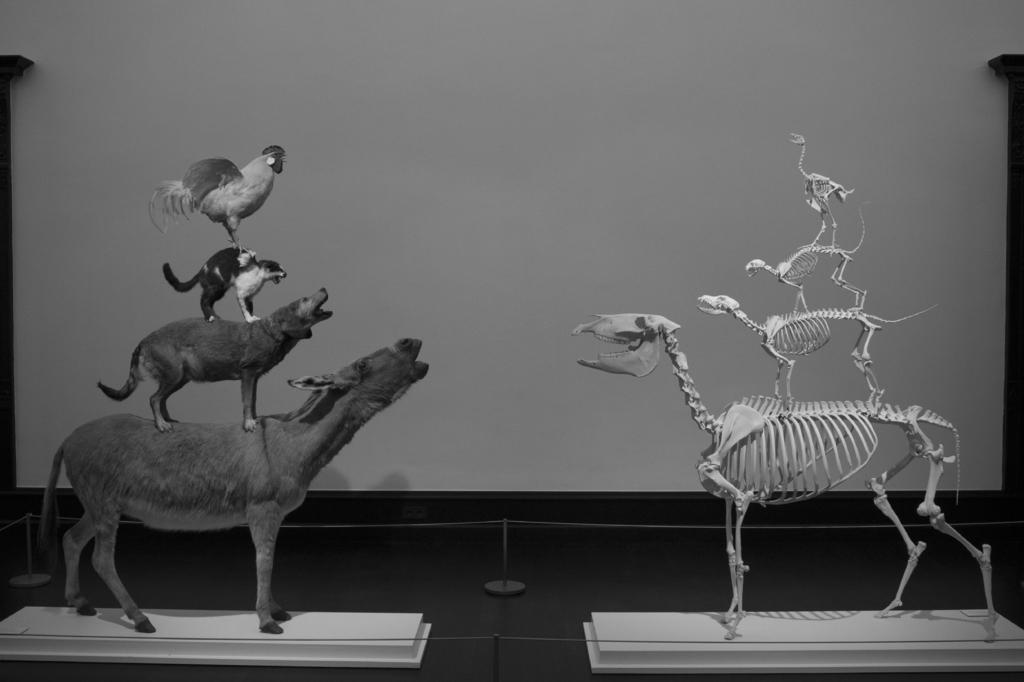What is the color scheme of the image? The image is black and white. What type of living creatures are present in the image? There are animals in the image, including a hen. What can be seen on the pedestals in the image? There are skeletons on pedestals in the image. What is visible in the background of the image? There is a wall in the background of the image. What type of pipe can be seen hanging from the wall in the image? There is no pipe visible in the image; it features a wall with skeletons on pedestals and a hen. What type of chin is visible on the hen in the image? The image is black and white, and it does not provide enough detail to determine the type of chin on the hen. 